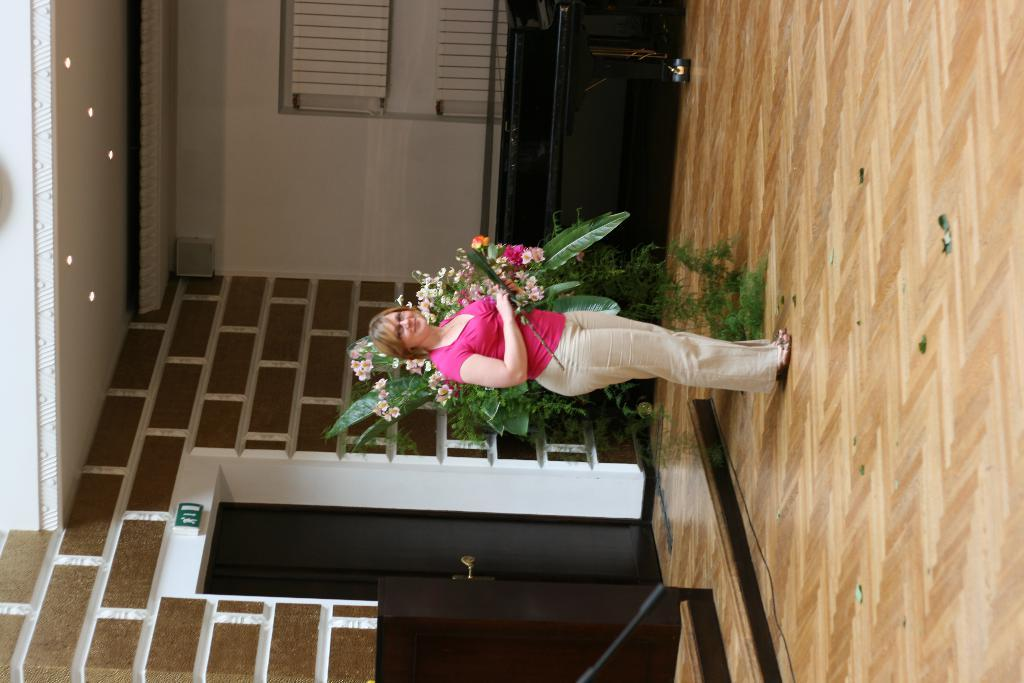What is the main subject of the image? There is a woman standing in the image. What is the woman wearing on her upper body? The woman is wearing a pink top. What is the woman wearing on her lower body? The woman is wearing white pants. What can be seen in the background of the image? There is a plant in the background of the image. Can you tell me how many dolls are sitting on the woman's lap in the image? There are no dolls present in the image; the woman is standing alone. What type of experience does the woman have with fire in the image? There is no mention of fire or any related experience in the image. 